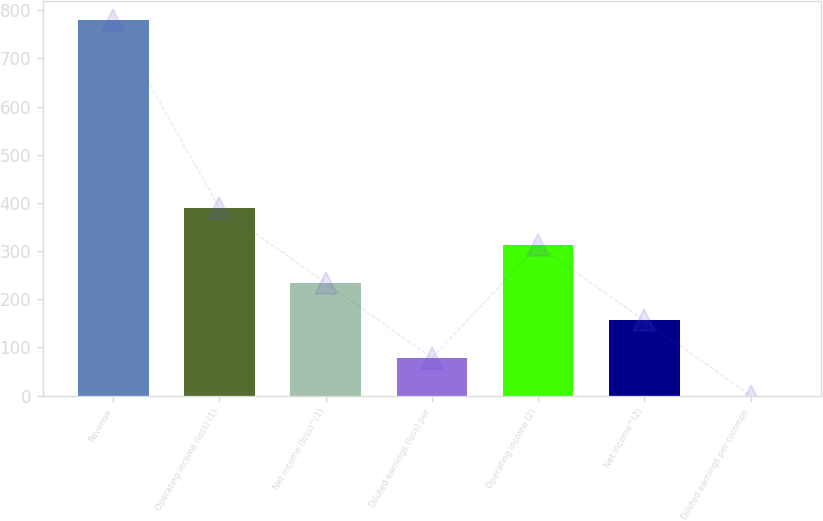Convert chart to OTSL. <chart><loc_0><loc_0><loc_500><loc_500><bar_chart><fcel>Revenue<fcel>Operating income (loss) (1)<fcel>Net income (loss)^(1)<fcel>Diluted earnings (loss) per<fcel>Operating income (2)<fcel>Net income^(2)<fcel>Diluted earnings per common<nl><fcel>779.2<fcel>389.73<fcel>233.95<fcel>78.17<fcel>311.84<fcel>156.06<fcel>0.28<nl></chart> 